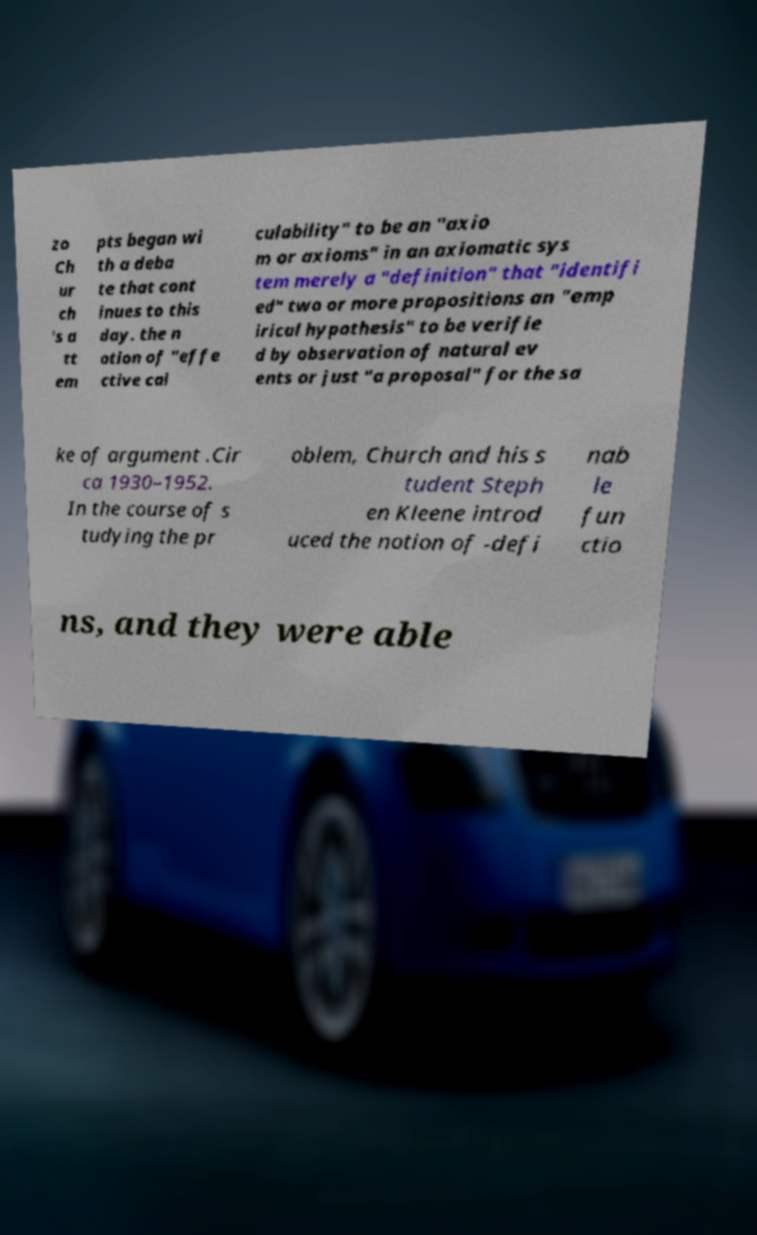Please read and relay the text visible in this image. What does it say? zo Ch ur ch 's a tt em pts began wi th a deba te that cont inues to this day. the n otion of "effe ctive cal culability" to be an "axio m or axioms" in an axiomatic sys tem merely a "definition" that "identifi ed" two or more propositions an "emp irical hypothesis" to be verifie d by observation of natural ev ents or just "a proposal" for the sa ke of argument .Cir ca 1930–1952. In the course of s tudying the pr oblem, Church and his s tudent Steph en Kleene introd uced the notion of -defi nab le fun ctio ns, and they were able 